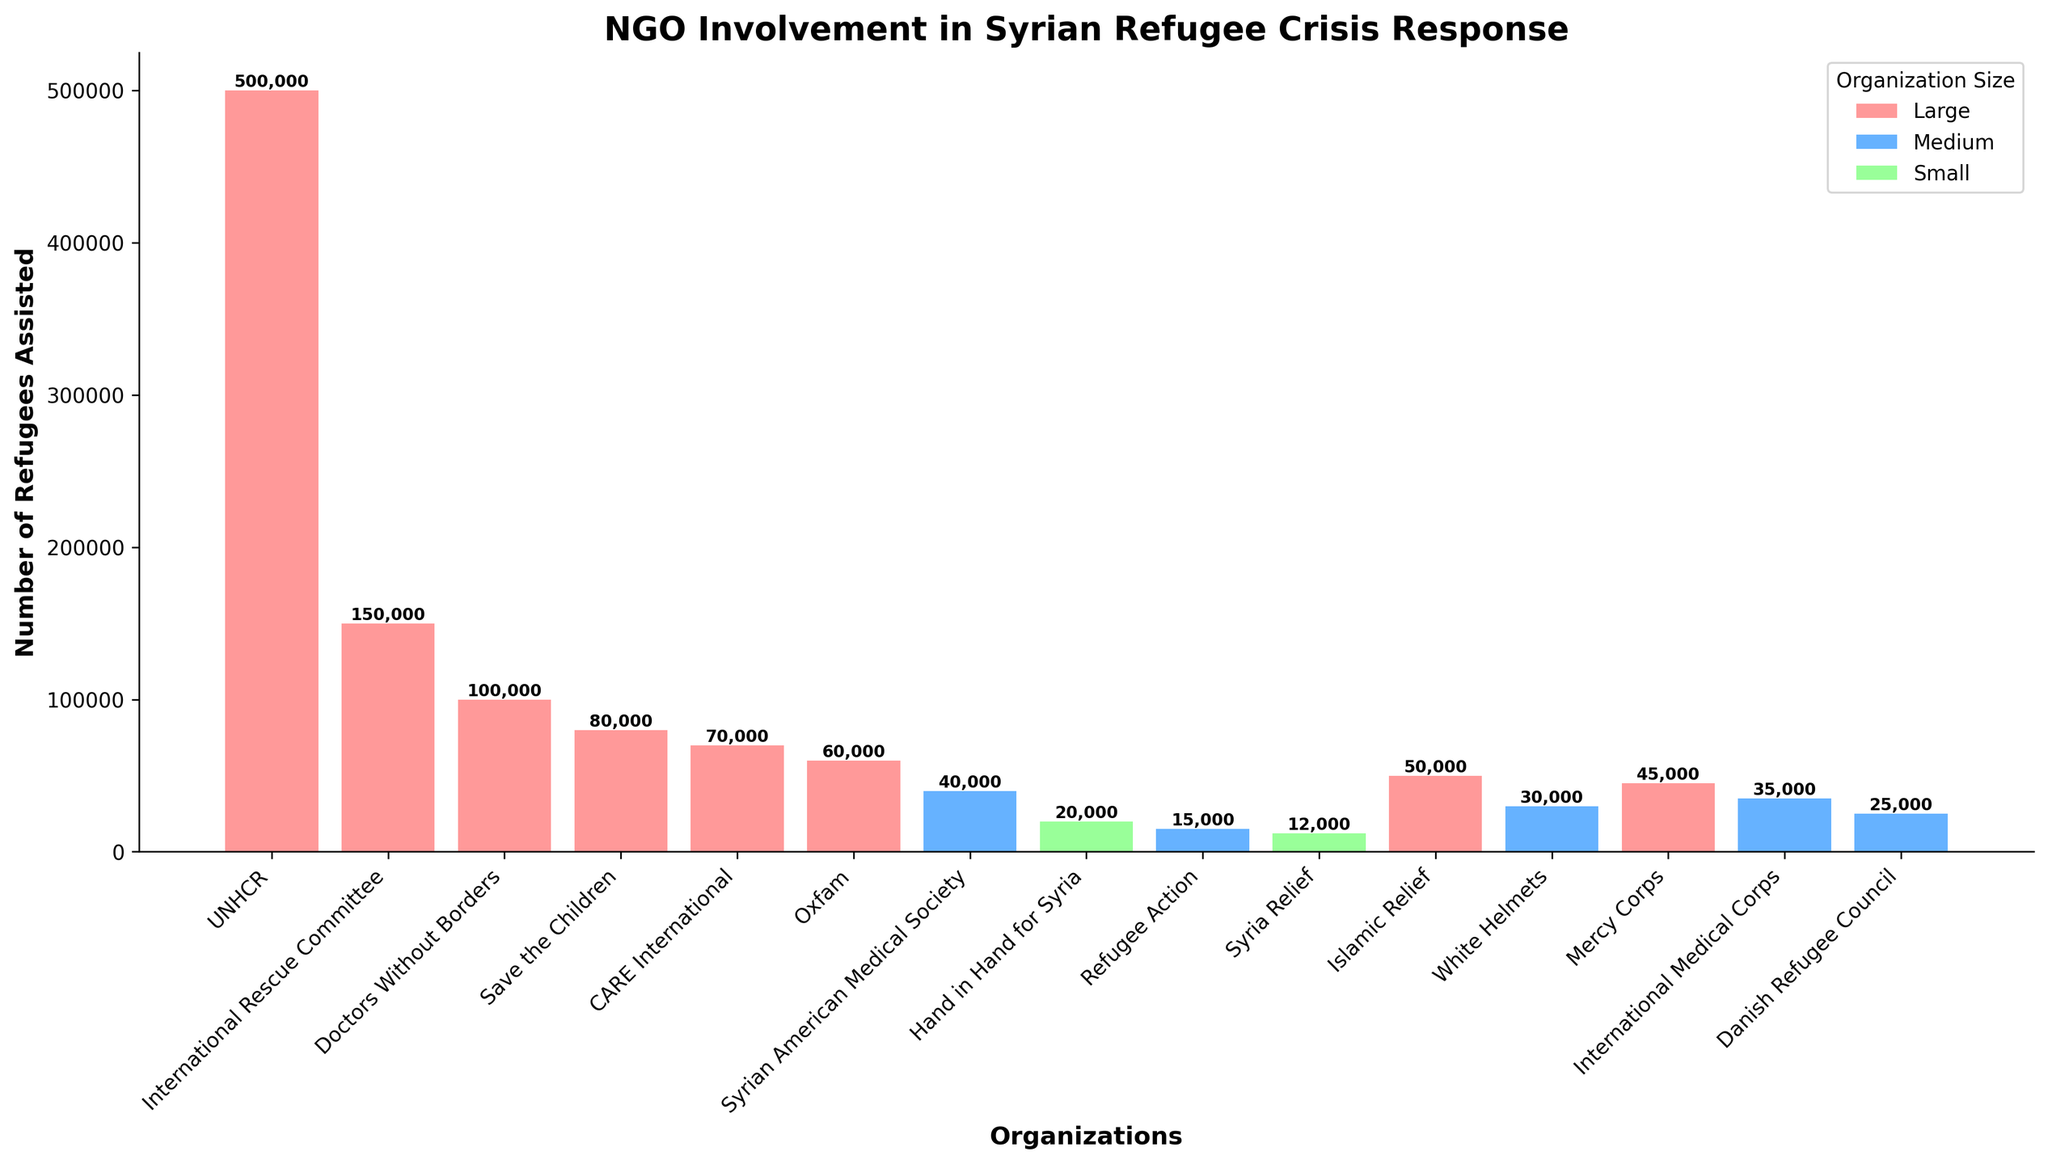Which organization assisted the most refugees? The organization with the tallest bar represents the one that assisted the most refugees. This is the UNHCR, with a bar height indicating 500,000 refugees assisted.
Answer: UNHCR Which organization assisted more refugees, Doctors Without Borders or Mercy Corps? By comparing the heights of the bars for Doctors Without Borders and Mercy Corps, Doctors Without Borders has a taller bar, indicating they assisted more refugees, with 100,000 versus Mercy Corps' 45,000.
Answer: Doctors Without Borders How many more refugees did the International Rescue Committee assist compared to Syrian American Medical Society? The International Rescue Committee assisted 150,000 refugees, while the Syrian American Medical Society assisted 40,000 refugees. The difference is calculated as 150,000 - 40,000.
Answer: 110,000 What is the total number of refugees assisted by medium-sized organizations? Sum the numbers of refugees assisted by medium-sized organizations: Syrian American Medical Society (40,000), Refugee Action (15,000), White Helmets (30,000), International Medical Corps (35,000), and Danish Refugee Council (25,000). Summation: 40,000 + 15,000 + 30,000 + 35,000 + 25,000.
Answer: 145,000 Which small organization assisted the fewest refugees? By observing the heights of the bars for small organizations (Hand in Hand for Syria and Syria Relief), the bar for Syria Relief is shorter, indicating they assisted the fewest refugees at 12,000.
Answer: Syria Relief How many refugees have been assisted by all organizations involved in Medical Aid combined? Sum the number of refugees assisted by organizations focused on Medical Aid: Doctors Without Borders (100,000) and Syrian American Medical Society (40,000), totaling 100,000 + 40,000.
Answer: 140,000 Which organization's bar is colored red and how many refugees did they assist? The color red represents large organizations. Among them, one organization's bar, specifically UNHCR, is tallest and thus stands out. UNHCR assisted 500,000 refugees, as indicated by the height of the red bar.
Answer: UNHCR, 500,000 Compare the number of refugees assisted by Oxfam and CARE International. Which one assisted more, and by how many? Oxfam assisted 60,000 refugees while CARE International assisted 70,000. CARE International assisted more, with the difference calculated as 70,000 - 60,000.
Answer: CARE International, 10,000 Which medium-sized organization is focused on Search and Rescue, and how many refugees did they assist? Among medium-sized organizations, the one focused on Search and Rescue, as indicated by the organization names and focus areas, is the White Helmets. They assisted 30,000 refugees.
Answer: White Helmets, 30,000 